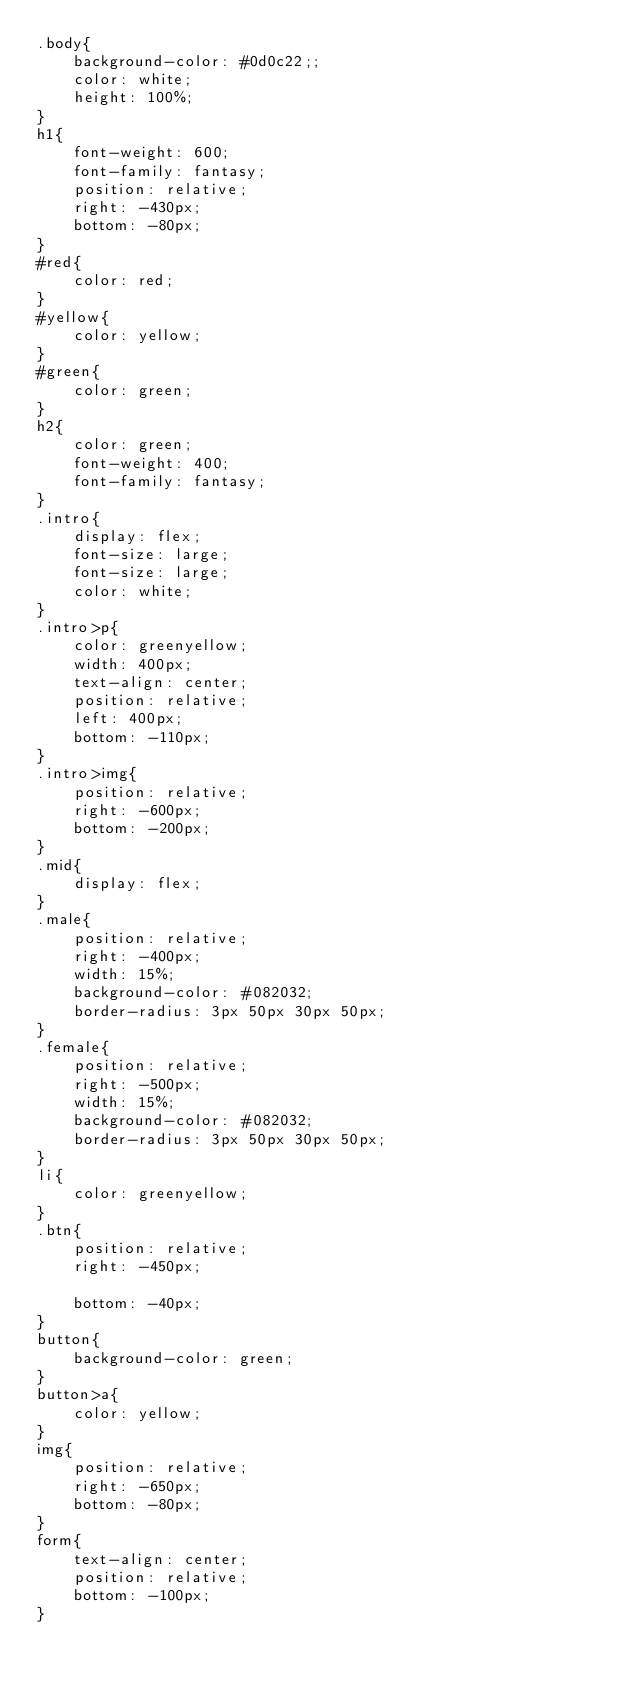<code> <loc_0><loc_0><loc_500><loc_500><_CSS_>.body{
    background-color: #0d0c22;;
    color: white;
    height: 100%;
}
h1{
    font-weight: 600;
    font-family: fantasy;
    position: relative;
    right: -430px;
    bottom: -80px;
}
#red{
    color: red;
}
#yellow{
    color: yellow;
}
#green{
    color: green;
}
h2{
    color: green;
    font-weight: 400;
    font-family: fantasy;
}
.intro{
    display: flex;
    font-size: large;
    font-size: large;
    color: white;
}
.intro>p{
    color: greenyellow;
    width: 400px;
    text-align: center;
    position: relative;
    left: 400px;
    bottom: -110px;
}
.intro>img{
    position: relative;
    right: -600px;
    bottom: -200px;
}
.mid{
    display: flex;
}
.male{
    position: relative;
    right: -400px;
    width: 15%;
    background-color: #082032;
    border-radius: 3px 50px 30px 50px;
}
.female{
    position: relative;
    right: -500px;
    width: 15%;
    background-color: #082032;
    border-radius: 3px 50px 30px 50px;
}
li{
    color: greenyellow;
}
.btn{
    position: relative;
    right: -450px;
  
    bottom: -40px;
}
button{
    background-color: green;
}
button>a{
    color: yellow;
}
img{
    position: relative;
    right: -650px;
    bottom: -80px;
}
form{
    text-align: center;
    position: relative;
    bottom: -100px;
}</code> 